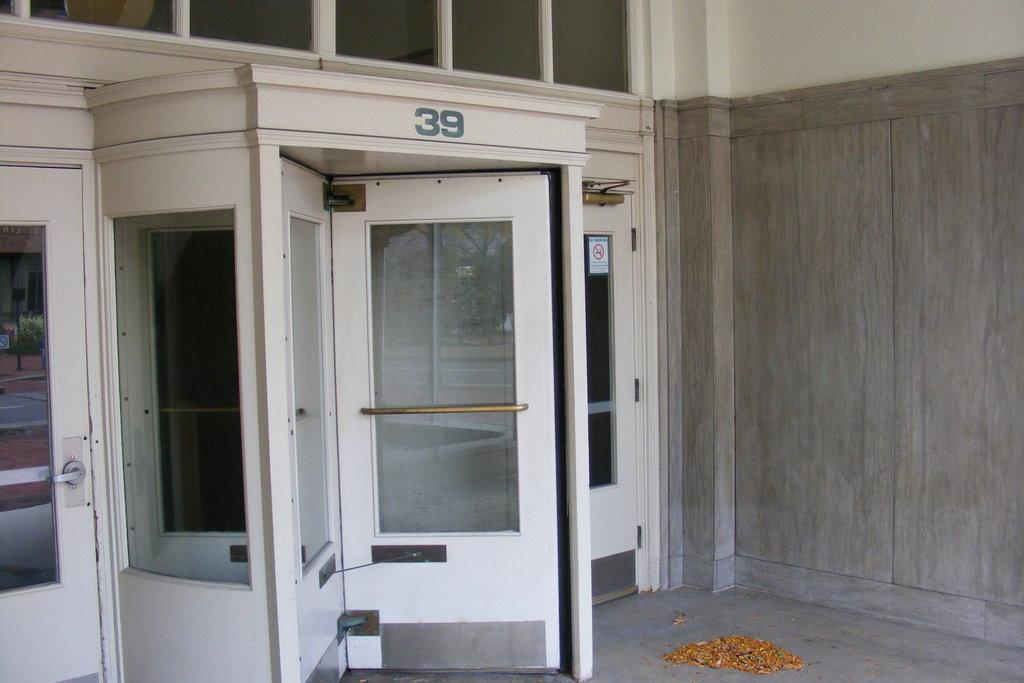What is the entrance number?
Offer a terse response. 39. Is the number 39 blue?
Ensure brevity in your answer.  Yes. 